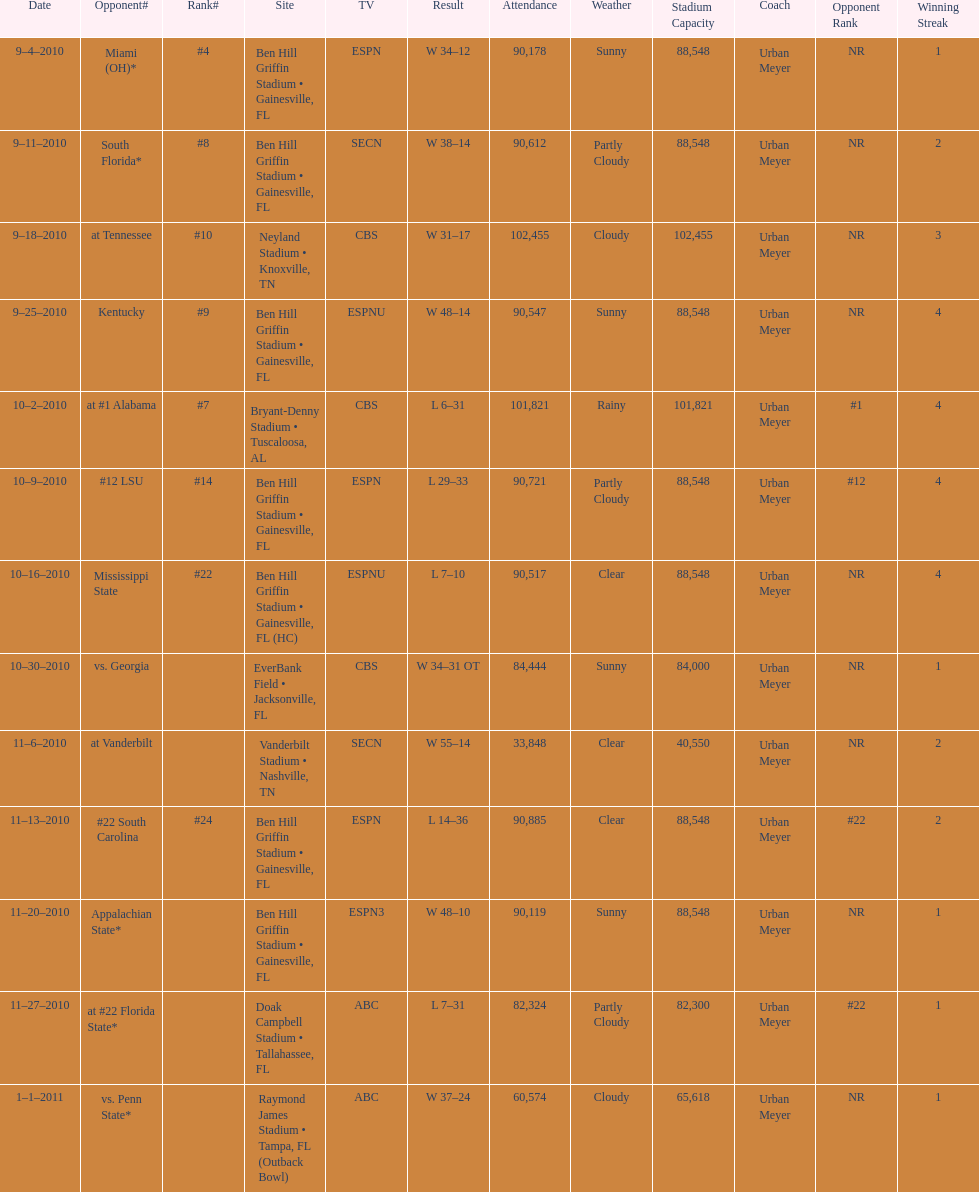How many games were played at the ben hill griffin stadium during the 2010-2011 season? 7. 